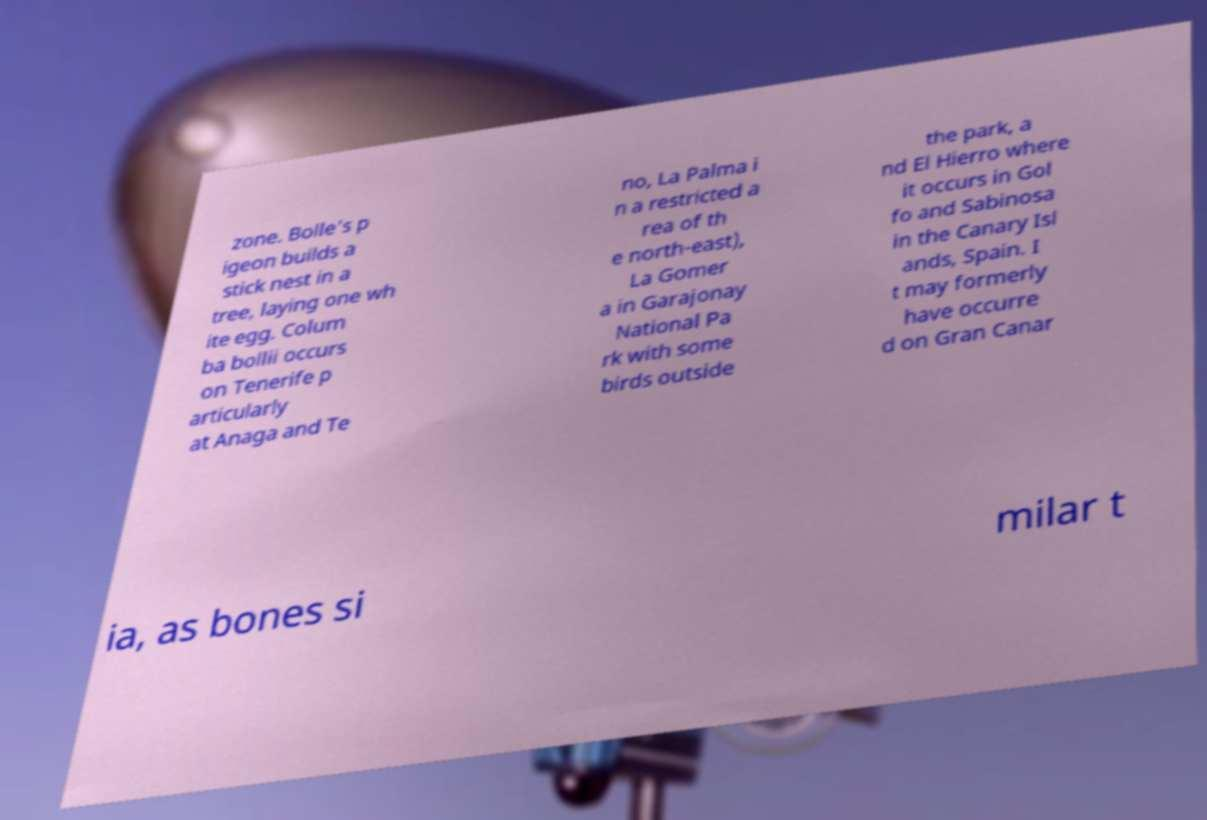I need the written content from this picture converted into text. Can you do that? zone. Bolle's p igeon builds a stick nest in a tree, laying one wh ite egg. Colum ba bollii occurs on Tenerife p articularly at Anaga and Te no, La Palma i n a restricted a rea of th e north-east), La Gomer a in Garajonay National Pa rk with some birds outside the park, a nd El Hierro where it occurs in Gol fo and Sabinosa in the Canary Isl ands, Spain. I t may formerly have occurre d on Gran Canar ia, as bones si milar t 